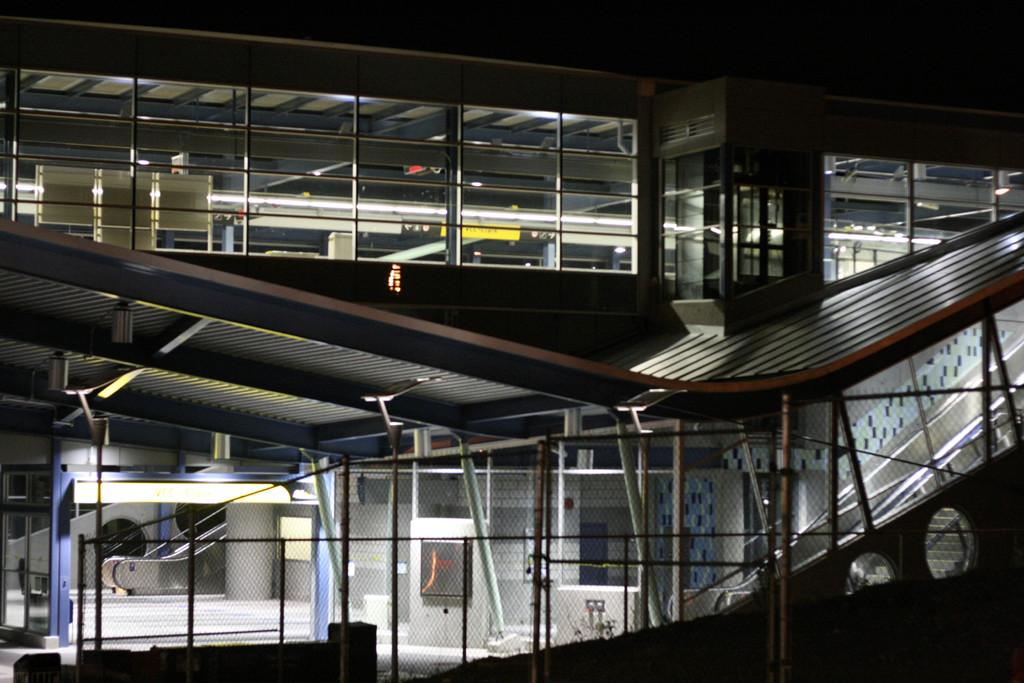What type of building is visible in the image? There is a building with glass windows in the image. Are there any structures near the building? Yes, there are poles near the building. What else can be seen near the building? There is a net near the building. What is the color of the background in the image? The background of the image is black. What type of meat is hanging from the poles in the image? There is no meat visible in the image; the poles are near a building with glass windows. 